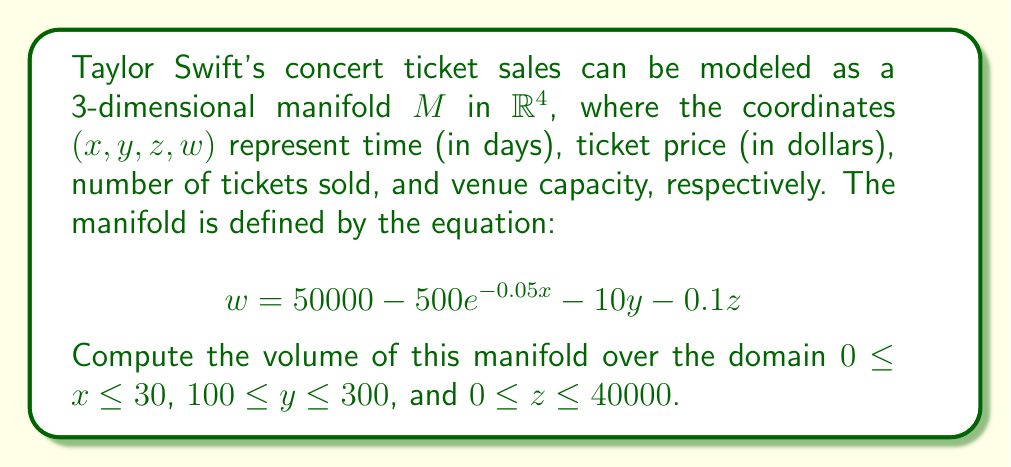Can you answer this question? To compute the volume of this manifold, we need to follow these steps:

1) First, we need to express $w$ in terms of $x$, $y$, and $z$. We already have this from the given equation.

2) The volume of a 3D manifold in 4D space is calculated using the triple integral:

   $$V = \iiint_D \sqrt{\left|\det\left(g_{ij}\right)\right|} \, dx \, dy \, dz$$

   where $g_{ij}$ is the metric tensor.

3) For a manifold defined by $w = f(x,y,z)$, the metric tensor is:

   $$g_{ij} = \begin{pmatrix}
   1 + (\frac{\partial f}{\partial x})^2 & \frac{\partial f}{\partial x}\frac{\partial f}{\partial y} & \frac{\partial f}{\partial x}\frac{\partial f}{\partial z} \\
   \frac{\partial f}{\partial y}\frac{\partial f}{\partial x} & 1 + (\frac{\partial f}{\partial y})^2 & \frac{\partial f}{\partial y}\frac{\partial f}{\partial z} \\
   \frac{\partial f}{\partial z}\frac{\partial f}{\partial x} & \frac{\partial f}{\partial z}\frac{\partial f}{\partial y} & 1 + (\frac{\partial f}{\partial z})^2
   \end{pmatrix}$$

4) Let's calculate the partial derivatives:
   
   $\frac{\partial f}{\partial x} = 25e^{-0.05x}$
   $\frac{\partial f}{\partial y} = -10$
   $\frac{\partial f}{\partial z} = -0.1$

5) Now we can construct the metric tensor:

   $$g_{ij} = \begin{pmatrix}
   1 + (25e^{-0.05x})^2 & -250e^{-0.05x} & -2.5e^{-0.05x} \\
   -250e^{-0.05x} & 101 & 1 \\
   -2.5e^{-0.05x} & 1 & 1.01
   \end{pmatrix}$$

6) The determinant of this matrix is:

   $$\det(g_{ij}) = 101.01 + (25e^{-0.05x})^2 - 62500e^{-0.1x} + 6.25e^{-0.1x}$$

7) Now we can set up our triple integral:

   $$V = \int_0^{30} \int_{100}^{300} \int_0^{40000} \sqrt{101.01 + (25e^{-0.05x})^2 - 62500e^{-0.1x} + 6.25e^{-0.1x}} \, dz \, dy \, dx$$

8) This integral is too complex to solve analytically, so we would need to use numerical methods to approximate the result.
Answer: The volume of the manifold can be approximated numerically using computational methods. The exact symbolic form of the answer is:

$$V = \int_0^{30} \int_{100}^{300} \int_0^{40000} \sqrt{101.01 + (25e^{-0.05x})^2 - 62500e^{-0.1x} + 6.25e^{-0.1x}} \, dz \, dy \, dx$$

The numerical value would depend on the precision of the numerical integration method used. 